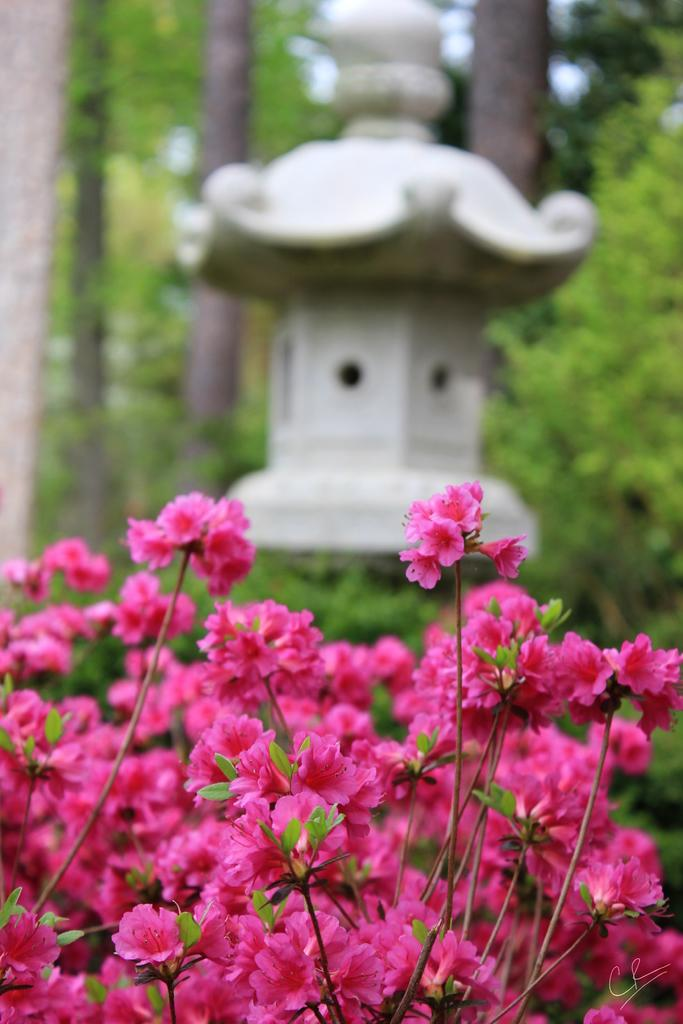What color are the flowers in the image? The flowers in the image are pink. What can be seen in the background of the image? There are many trees in the background of the image. What is the color of the object in the middle of the image? The object in the middle of the image is white. Can you see a dog playing with a cat in the image? There is no dog or cat present in the image. Who is the friend standing next to the white object in the image? There is no person, including a friend, present in the image. 